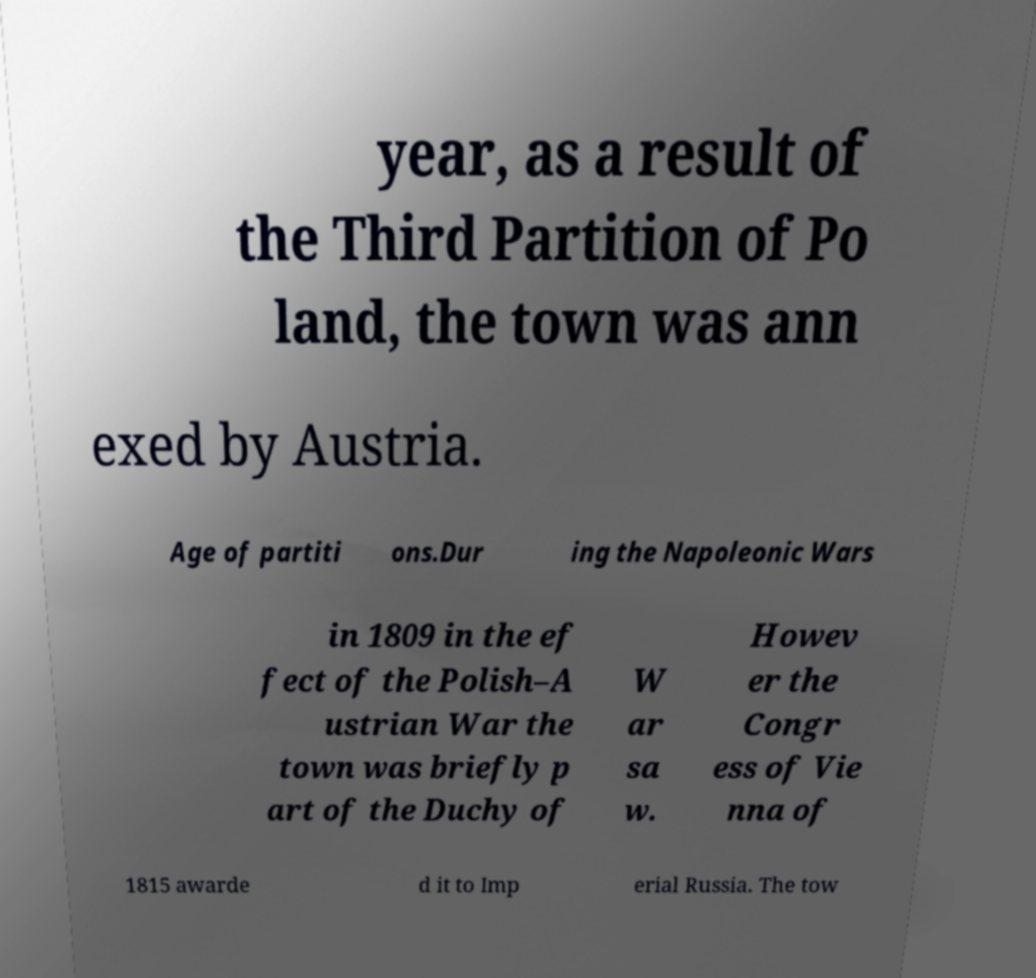Please read and relay the text visible in this image. What does it say? year, as a result of the Third Partition of Po land, the town was ann exed by Austria. Age of partiti ons.Dur ing the Napoleonic Wars in 1809 in the ef fect of the Polish–A ustrian War the town was briefly p art of the Duchy of W ar sa w. Howev er the Congr ess of Vie nna of 1815 awarde d it to Imp erial Russia. The tow 